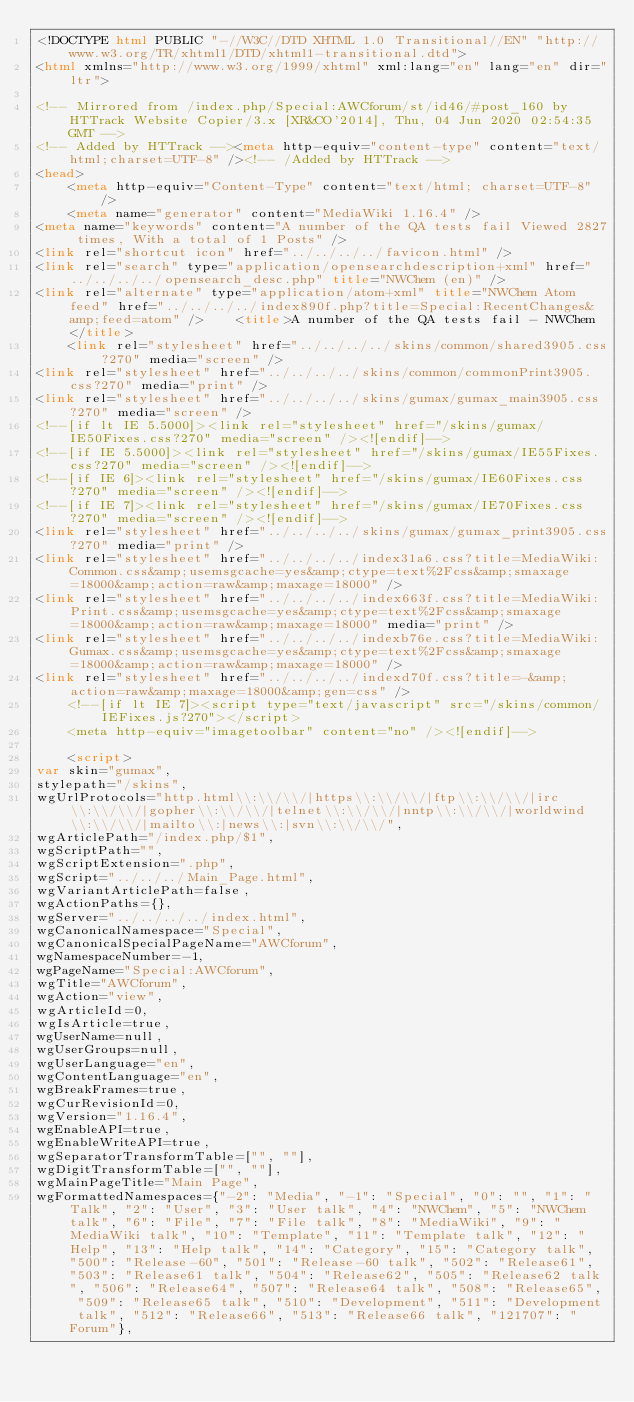Convert code to text. <code><loc_0><loc_0><loc_500><loc_500><_HTML_><!DOCTYPE html PUBLIC "-//W3C//DTD XHTML 1.0 Transitional//EN" "http://www.w3.org/TR/xhtml1/DTD/xhtml1-transitional.dtd">
<html xmlns="http://www.w3.org/1999/xhtml" xml:lang="en" lang="en" dir="ltr">
	
<!-- Mirrored from /index.php/Special:AWCforum/st/id46/#post_160 by HTTrack Website Copier/3.x [XR&CO'2014], Thu, 04 Jun 2020 02:54:35 GMT -->
<!-- Added by HTTrack --><meta http-equiv="content-type" content="text/html;charset=UTF-8" /><!-- /Added by HTTrack -->
<head>
		<meta http-equiv="Content-Type" content="text/html; charset=UTF-8" />
		<meta name="generator" content="MediaWiki 1.16.4" />
<meta name="keywords" content="A number of the QA tests fail Viewed 2827 times, With a total of 1 Posts" />
<link rel="shortcut icon" href="../../../../favicon.html" />
<link rel="search" type="application/opensearchdescription+xml" href="../../../../opensearch_desc.php" title="NWChem (en)" />
<link rel="alternate" type="application/atom+xml" title="NWChem Atom feed" href="../../../../index890f.php?title=Special:RecentChanges&amp;feed=atom" />		<title>A number of the QA tests fail - NWChem</title>
		<link rel="stylesheet" href="../../../../skins/common/shared3905.css?270" media="screen" />
<link rel="stylesheet" href="../../../../skins/common/commonPrint3905.css?270" media="print" />
<link rel="stylesheet" href="../../../../skins/gumax/gumax_main3905.css?270" media="screen" />
<!--[if lt IE 5.5000]><link rel="stylesheet" href="/skins/gumax/IE50Fixes.css?270" media="screen" /><![endif]-->
<!--[if IE 5.5000]><link rel="stylesheet" href="/skins/gumax/IE55Fixes.css?270" media="screen" /><![endif]-->
<!--[if IE 6]><link rel="stylesheet" href="/skins/gumax/IE60Fixes.css?270" media="screen" /><![endif]-->
<!--[if IE 7]><link rel="stylesheet" href="/skins/gumax/IE70Fixes.css?270" media="screen" /><![endif]-->
<link rel="stylesheet" href="../../../../skins/gumax/gumax_print3905.css?270" media="print" />
<link rel="stylesheet" href="../../../../index31a6.css?title=MediaWiki:Common.css&amp;usemsgcache=yes&amp;ctype=text%2Fcss&amp;smaxage=18000&amp;action=raw&amp;maxage=18000" />
<link rel="stylesheet" href="../../../../index663f.css?title=MediaWiki:Print.css&amp;usemsgcache=yes&amp;ctype=text%2Fcss&amp;smaxage=18000&amp;action=raw&amp;maxage=18000" media="print" />
<link rel="stylesheet" href="../../../../indexb76e.css?title=MediaWiki:Gumax.css&amp;usemsgcache=yes&amp;ctype=text%2Fcss&amp;smaxage=18000&amp;action=raw&amp;maxage=18000" />
<link rel="stylesheet" href="../../../../indexd70f.css?title=-&amp;action=raw&amp;maxage=18000&amp;gen=css" />
		<!--[if lt IE 7]><script type="text/javascript" src="/skins/common/IEFixes.js?270"></script>
		<meta http-equiv="imagetoolbar" content="no" /><![endif]-->

		<script>
var skin="gumax",
stylepath="/skins",
wgUrlProtocols="http.html\\:\\/\\/|https\\:\\/\\/|ftp\\:\\/\\/|irc\\:\\/\\/|gopher\\:\\/\\/|telnet\\:\\/\\/|nntp\\:\\/\\/|worldwind\\:\\/\\/|mailto\\:|news\\:|svn\\:\\/\\/",
wgArticlePath="/index.php/$1",
wgScriptPath="",
wgScriptExtension=".php",
wgScript="../../../Main_Page.html",
wgVariantArticlePath=false,
wgActionPaths={},
wgServer="../../../../index.html",
wgCanonicalNamespace="Special",
wgCanonicalSpecialPageName="AWCforum",
wgNamespaceNumber=-1,
wgPageName="Special:AWCforum",
wgTitle="AWCforum",
wgAction="view",
wgArticleId=0,
wgIsArticle=true,
wgUserName=null,
wgUserGroups=null,
wgUserLanguage="en",
wgContentLanguage="en",
wgBreakFrames=true,
wgCurRevisionId=0,
wgVersion="1.16.4",
wgEnableAPI=true,
wgEnableWriteAPI=true,
wgSeparatorTransformTable=["", ""],
wgDigitTransformTable=["", ""],
wgMainPageTitle="Main Page",
wgFormattedNamespaces={"-2": "Media", "-1": "Special", "0": "", "1": "Talk", "2": "User", "3": "User talk", "4": "NWChem", "5": "NWChem talk", "6": "File", "7": "File talk", "8": "MediaWiki", "9": "MediaWiki talk", "10": "Template", "11": "Template talk", "12": "Help", "13": "Help talk", "14": "Category", "15": "Category talk", "500": "Release-60", "501": "Release-60 talk", "502": "Release61", "503": "Release61 talk", "504": "Release62", "505": "Release62 talk", "506": "Release64", "507": "Release64 talk", "508": "Release65", "509": "Release65 talk", "510": "Development", "511": "Development talk", "512": "Release66", "513": "Release66 talk", "121707": "Forum"},</code> 